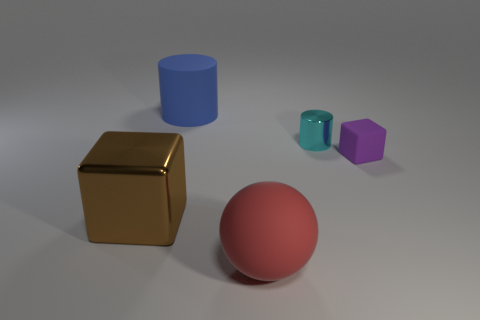What materials do the objects in the image look like they're made of? The objects appear to have different materials: the gold cube looks metallic, the red sphere seems like a matte plastic, the blue cylinder could be a satin-finish plastic, and the small cyan cylinder and purple pentagonal prism also suggest a plastic material with a matte finish. 